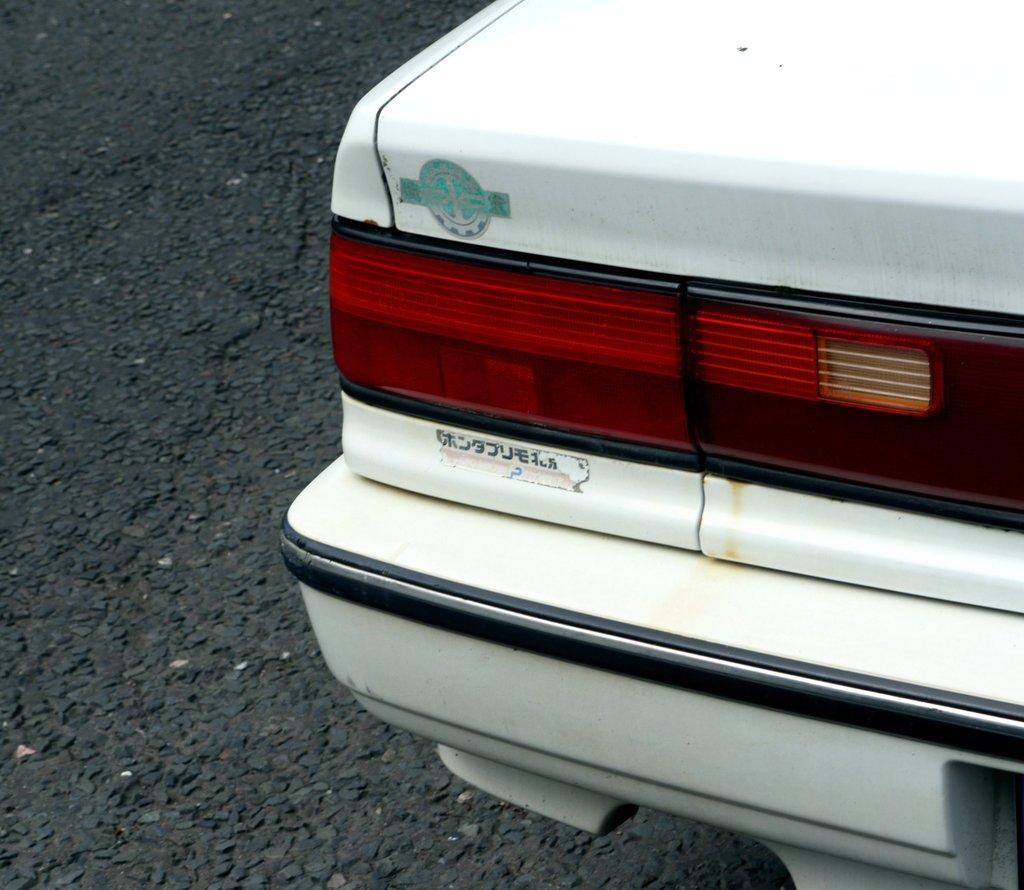Can you describe this image briefly? In this image there is a car towards the right of the image, there is text on the car, there is road towards the left of the image. 